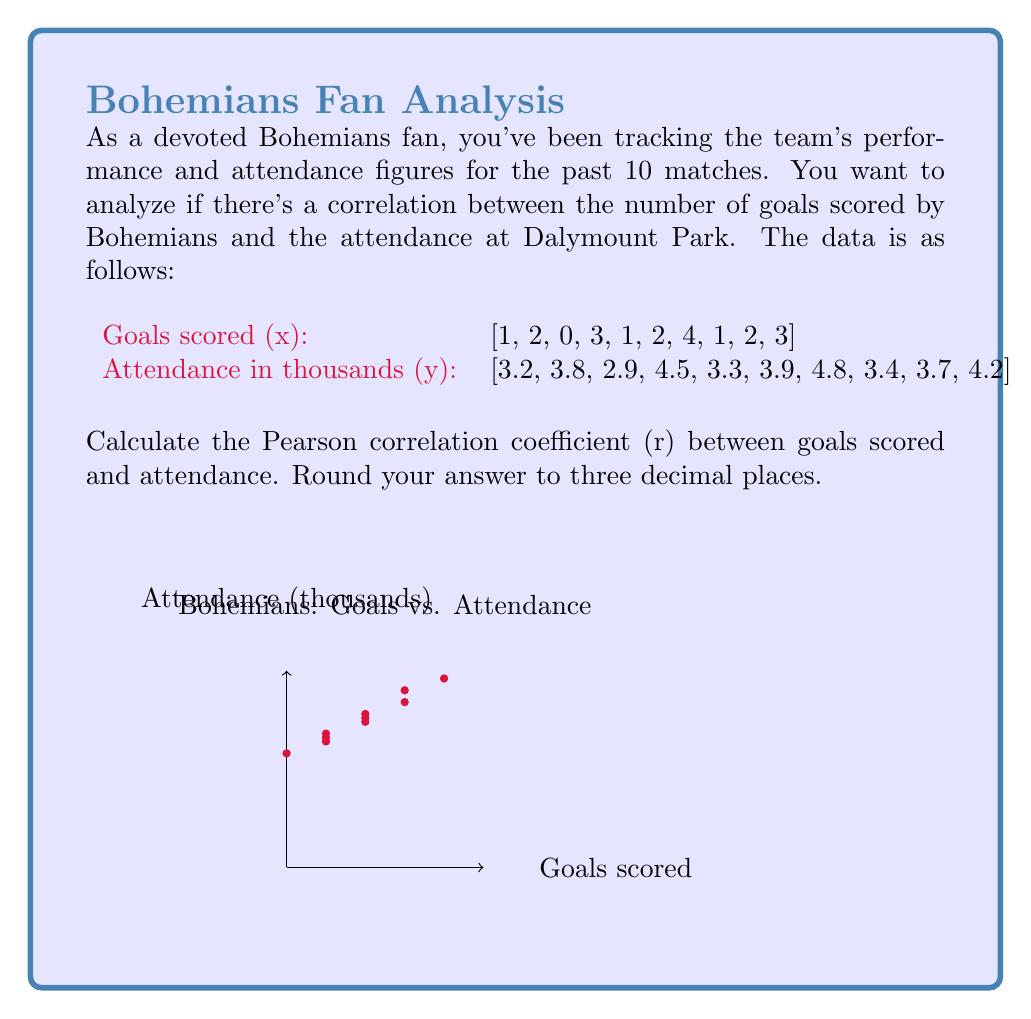Help me with this question. To calculate the Pearson correlation coefficient (r), we'll use the formula:

$$ r = \frac{\sum_{i=1}^{n} (x_i - \bar{x})(y_i - \bar{y})}{\sqrt{\sum_{i=1}^{n} (x_i - \bar{x})^2 \sum_{i=1}^{n} (y_i - \bar{y})^2}} $$

Where $\bar{x}$ and $\bar{y}$ are the means of x and y respectively.

Step 1: Calculate the means
$\bar{x} = \frac{1+2+0+3+1+2+4+1+2+3}{10} = 1.9$
$\bar{y} = \frac{3.2+3.8+2.9+4.5+3.3+3.9+4.8+3.4+3.7+4.2}{10} = 3.77$

Step 2: Calculate $(x_i - \bar{x})$, $(y_i - \bar{y})$, $(x_i - \bar{x})^2$, $(y_i - \bar{y})^2$, and $(x_i - \bar{x})(y_i - \bar{y})$ for each pair.

Step 3: Sum up the results:
$\sum (x_i - \bar{x})(y_i - \bar{y}) = 2.79$
$\sum (x_i - \bar{x})^2 = 11.9$
$\sum (y_i - \bar{y})^2 = 2.8890$

Step 4: Apply the formula:

$$ r = \frac{2.79}{\sqrt{11.9 \times 2.8890}} = \frac{2.79}{\sqrt{34.3791}} = \frac{2.79}{5.8633} = 0.47585 $$

Step 5: Round to three decimal places: 0.476
Answer: 0.476 